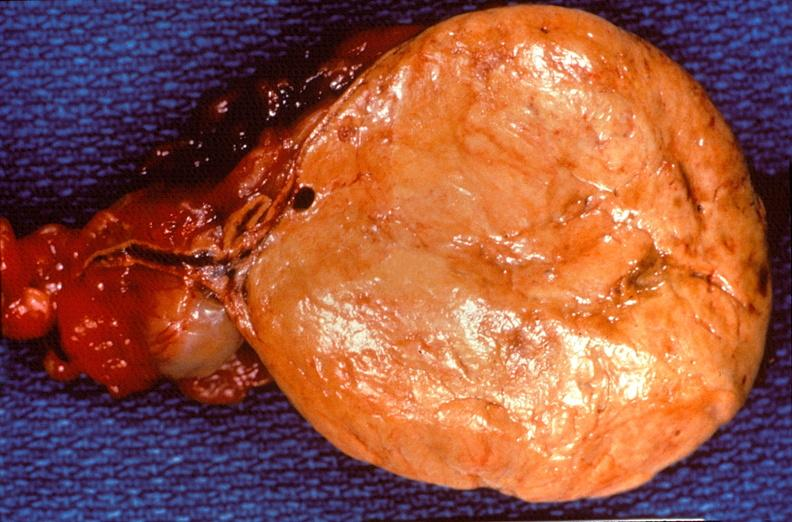what is present?
Answer the question using a single word or phrase. Endocrine 